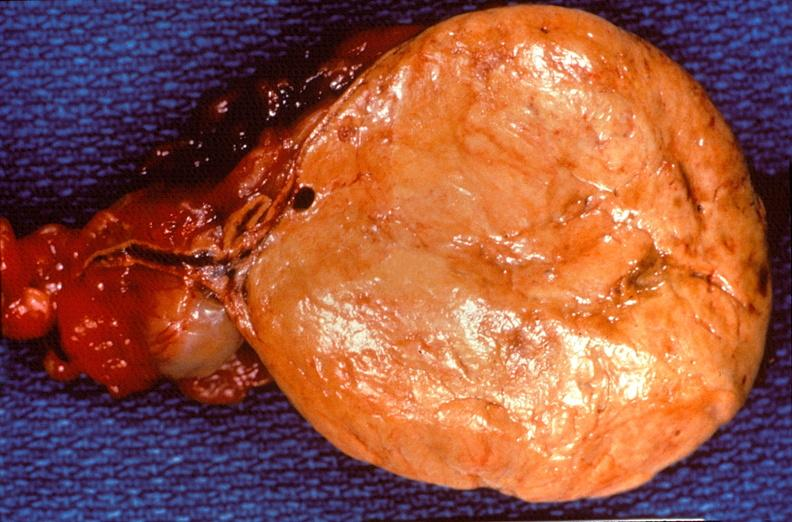what is present?
Answer the question using a single word or phrase. Endocrine 